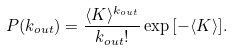Convert formula to latex. <formula><loc_0><loc_0><loc_500><loc_500>P ( k _ { o u t } ) = \frac { \langle K \rangle ^ { k _ { o u t } } } { k _ { o u t } ! } \exp { [ - \langle K \rangle ] } .</formula> 